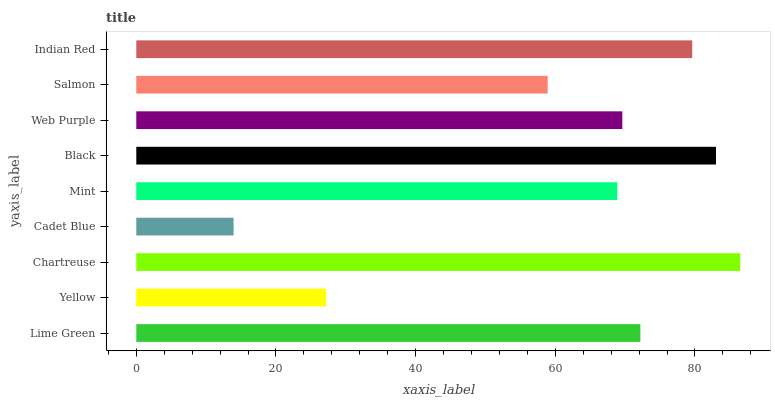Is Cadet Blue the minimum?
Answer yes or no. Yes. Is Chartreuse the maximum?
Answer yes or no. Yes. Is Yellow the minimum?
Answer yes or no. No. Is Yellow the maximum?
Answer yes or no. No. Is Lime Green greater than Yellow?
Answer yes or no. Yes. Is Yellow less than Lime Green?
Answer yes or no. Yes. Is Yellow greater than Lime Green?
Answer yes or no. No. Is Lime Green less than Yellow?
Answer yes or no. No. Is Web Purple the high median?
Answer yes or no. Yes. Is Web Purple the low median?
Answer yes or no. Yes. Is Cadet Blue the high median?
Answer yes or no. No. Is Cadet Blue the low median?
Answer yes or no. No. 